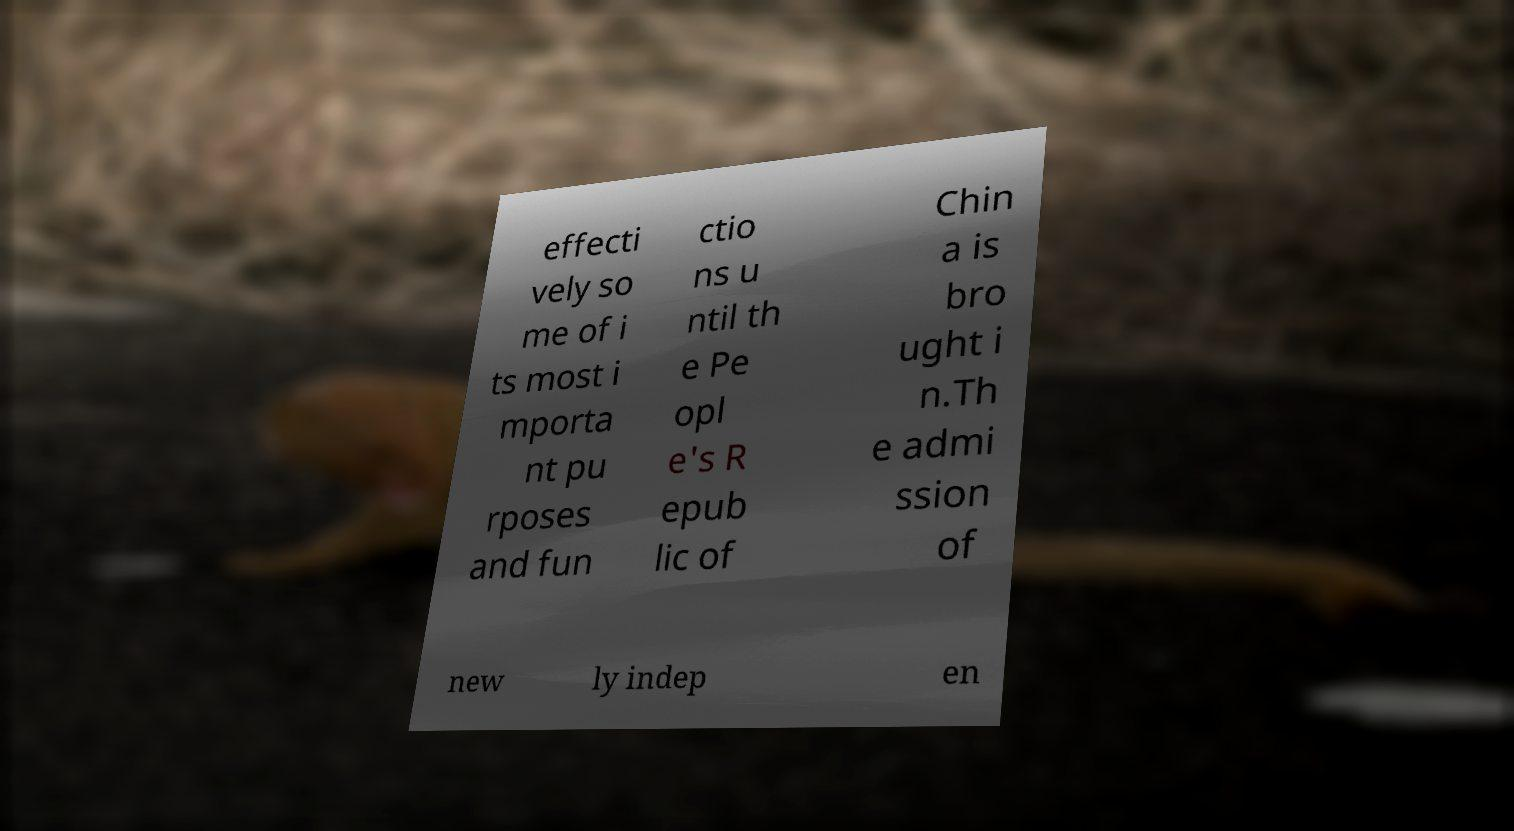For documentation purposes, I need the text within this image transcribed. Could you provide that? effecti vely so me of i ts most i mporta nt pu rposes and fun ctio ns u ntil th e Pe opl e's R epub lic of Chin a is bro ught i n.Th e admi ssion of new ly indep en 